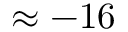Convert formula to latex. <formula><loc_0><loc_0><loc_500><loc_500>\approx - 1 6</formula> 